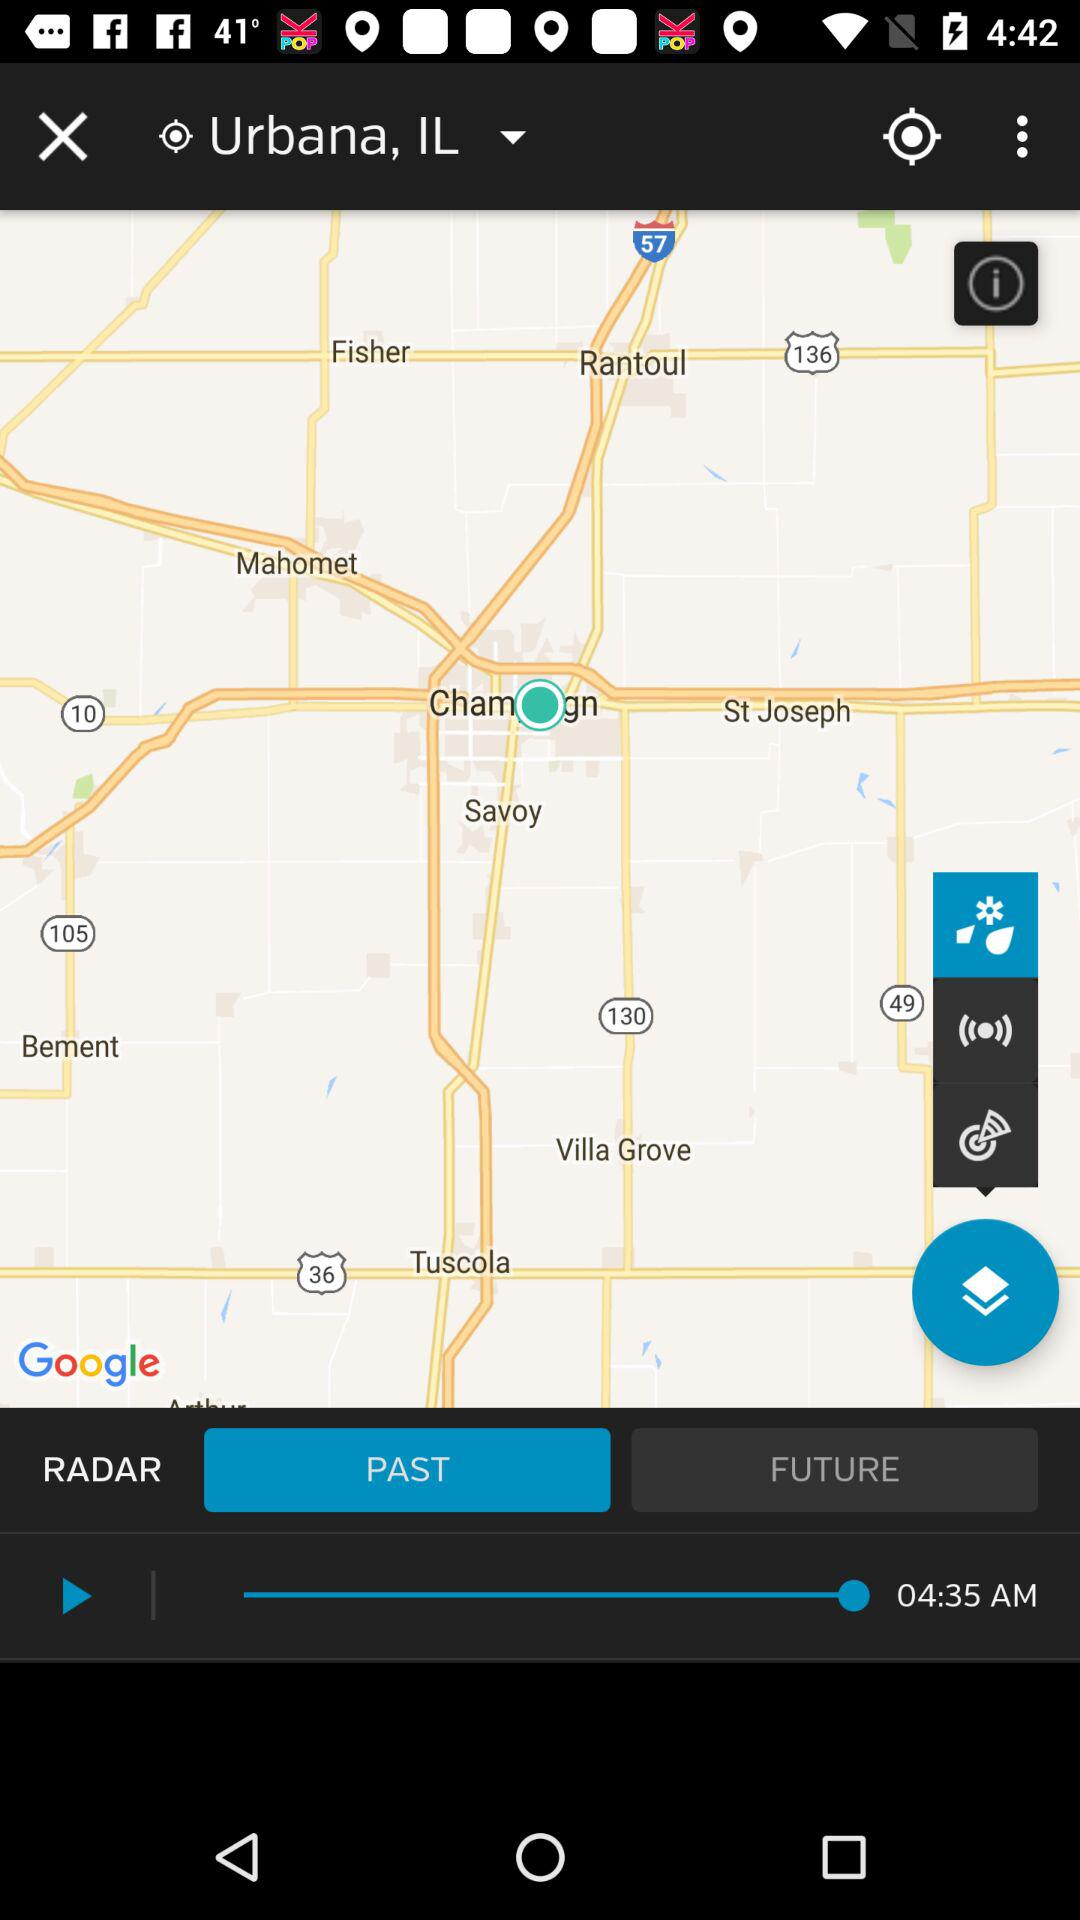What is the time? The time is 4:35 a.m. 